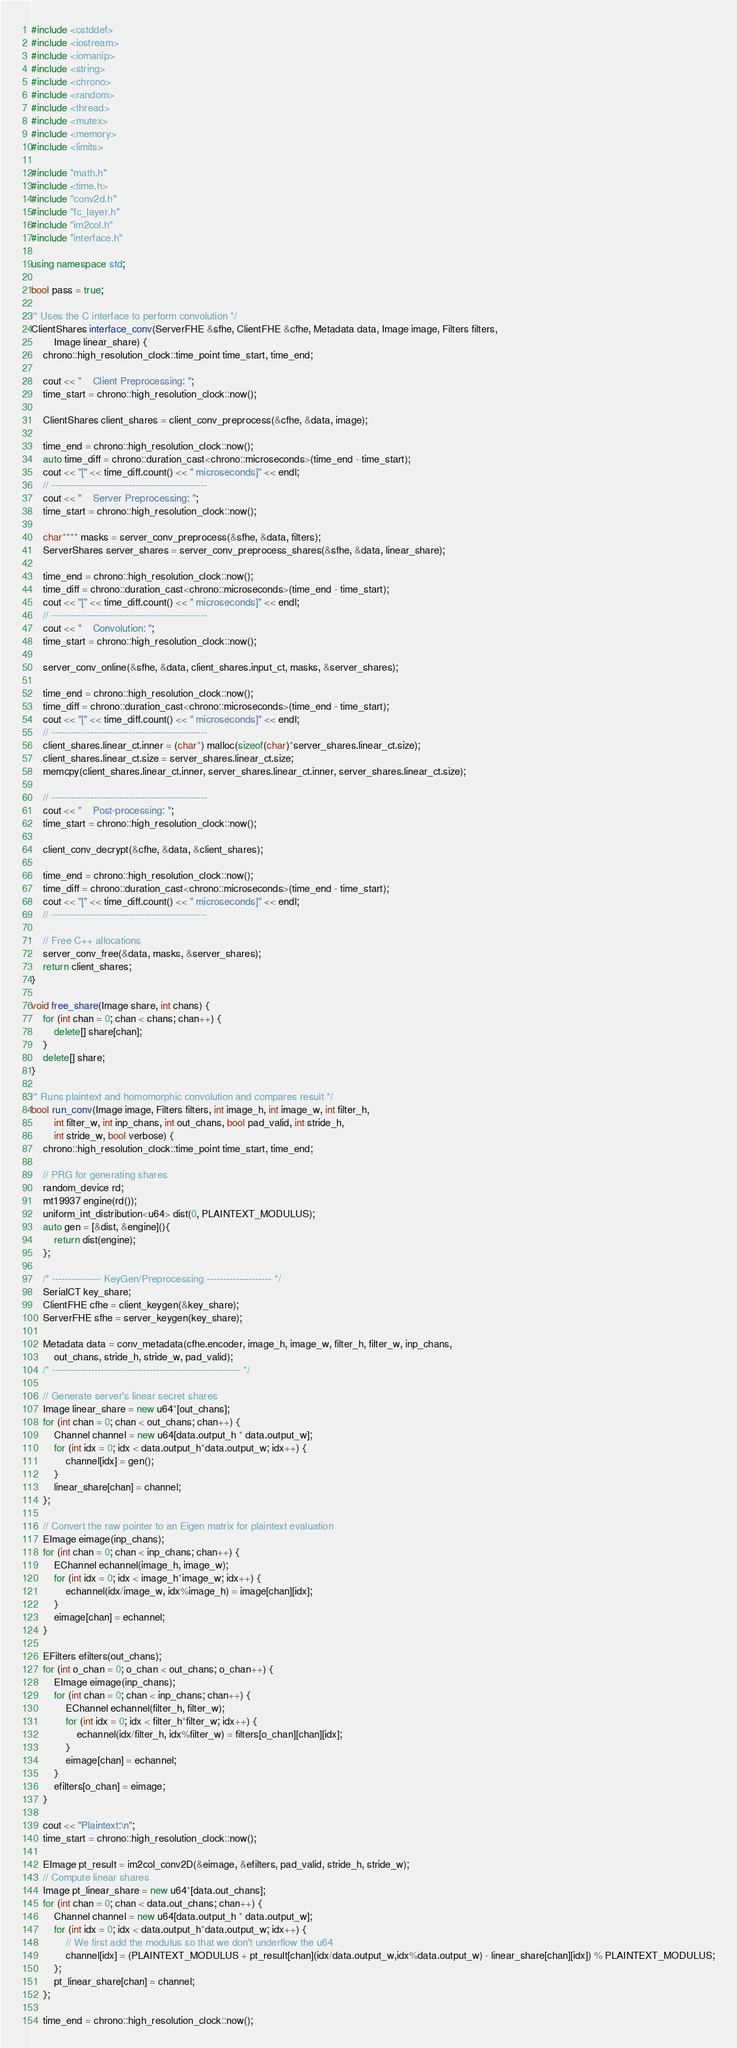<code> <loc_0><loc_0><loc_500><loc_500><_C++_>#include <cstddef>
#include <iostream>
#include <iomanip>
#include <string>
#include <chrono>
#include <random>
#include <thread>
#include <mutex>
#include <memory>
#include <limits>

#include "math.h"
#include <time.h>
#include "conv2d.h"
#include "fc_layer.h"
#include "im2col.h"
#include "interface.h"

using namespace std;

bool pass = true;

/* Uses the C interface to perform convolution */
ClientShares interface_conv(ServerFHE &sfhe, ClientFHE &cfhe, Metadata data, Image image, Filters filters,
        Image linear_share) {
    chrono::high_resolution_clock::time_point time_start, time_end;

    cout << "    Client Preprocessing: ";
    time_start = chrono::high_resolution_clock::now();

    ClientShares client_shares = client_conv_preprocess(&cfhe, &data, image);
    
    time_end = chrono::high_resolution_clock::now();
    auto time_diff = chrono::duration_cast<chrono::microseconds>(time_end - time_start);
    cout << "[" << time_diff.count() << " microseconds]" << endl;
    // ------------------------------------------------ 
    cout << "    Server Preprocessing: ";
    time_start = chrono::high_resolution_clock::now();

    char**** masks = server_conv_preprocess(&sfhe, &data, filters);
    ServerShares server_shares = server_conv_preprocess_shares(&sfhe, &data, linear_share);
    
    time_end = chrono::high_resolution_clock::now();
    time_diff = chrono::duration_cast<chrono::microseconds>(time_end - time_start);
    cout << "[" << time_diff.count() << " microseconds]" << endl;
    // ------------------------------------------------ 
    cout << "    Convolution: ";
    time_start = chrono::high_resolution_clock::now();
    
    server_conv_online(&sfhe, &data, client_shares.input_ct, masks, &server_shares);
    
    time_end = chrono::high_resolution_clock::now();
    time_diff = chrono::duration_cast<chrono::microseconds>(time_end - time_start);
    cout << "[" << time_diff.count() << " microseconds]" << endl;
    // ------------------------------------------------ 
    client_shares.linear_ct.inner = (char*) malloc(sizeof(char)*server_shares.linear_ct.size);
    client_shares.linear_ct.size = server_shares.linear_ct.size;
    memcpy(client_shares.linear_ct.inner, server_shares.linear_ct.inner, server_shares.linear_ct.size);

    // ------------------------------------------------ 
    cout << "    Post-processing: ";
    time_start = chrono::high_resolution_clock::now();

    client_conv_decrypt(&cfhe, &data, &client_shares);
    
    time_end = chrono::high_resolution_clock::now();
    time_diff = chrono::duration_cast<chrono::microseconds>(time_end - time_start);
    cout << "[" << time_diff.count() << " microseconds]" << endl;
    // ------------------------------------------------ 
  
    // Free C++ allocations
    server_conv_free(&data, masks, &server_shares);
    return client_shares;
}

void free_share(Image share, int chans) {
    for (int chan = 0; chan < chans; chan++) {
        delete[] share[chan];
    }
    delete[] share;
}

/* Runs plaintext and homomorphic convolution and compares result */
bool run_conv(Image image, Filters filters, int image_h, int image_w, int filter_h,
        int filter_w, int inp_chans, int out_chans, bool pad_valid, int stride_h,
        int stride_w, bool verbose) {
    chrono::high_resolution_clock::time_point time_start, time_end;
    
    // PRG for generating shares
    random_device rd;
    mt19937 engine(rd());
    uniform_int_distribution<u64> dist(0, PLAINTEXT_MODULUS);
    auto gen = [&dist, &engine](){
        return dist(engine);
    };

    /* --------------- KeyGen/Preprocessing -------------------- */
    SerialCT key_share;
    ClientFHE cfhe = client_keygen(&key_share);
    ServerFHE sfhe = server_keygen(key_share); 
    
    Metadata data = conv_metadata(cfhe.encoder, image_h, image_w, filter_h, filter_w, inp_chans, 
        out_chans, stride_h, stride_w, pad_valid);
    /* ---------------------------------------------------------- */

    // Generate server's linear secret shares
    Image linear_share = new u64*[out_chans];
    for (int chan = 0; chan < out_chans; chan++) {
        Channel channel = new u64[data.output_h * data.output_w];
        for (int idx = 0; idx < data.output_h*data.output_w; idx++) {
            channel[idx] = gen();
        }
        linear_share[chan] = channel;
    };

    // Convert the raw pointer to an Eigen matrix for plaintext evaluation
    EImage eimage(inp_chans);
    for (int chan = 0; chan < inp_chans; chan++) {
        EChannel echannel(image_h, image_w);
        for (int idx = 0; idx < image_h*image_w; idx++) {
            echannel(idx/image_w, idx%image_h) = image[chan][idx];
        }
        eimage[chan] = echannel;
    }

    EFilters efilters(out_chans);
    for (int o_chan = 0; o_chan < out_chans; o_chan++) {
        EImage eimage(inp_chans);
        for (int chan = 0; chan < inp_chans; chan++) {
            EChannel echannel(filter_h, filter_w);
            for (int idx = 0; idx < filter_h*filter_w; idx++) {
                echannel(idx/filter_h, idx%filter_w) = filters[o_chan][chan][idx];
            }
            eimage[chan] = echannel;
        }
        efilters[o_chan] = eimage;
    }

    cout << "Plaintext:\n";
    time_start = chrono::high_resolution_clock::now();

    EImage pt_result = im2col_conv2D(&eimage, &efilters, pad_valid, stride_h, stride_w);
    // Compute linear shares 
    Image pt_linear_share = new u64*[data.out_chans];
    for (int chan = 0; chan < data.out_chans; chan++) {
        Channel channel = new u64[data.output_h * data.output_w];
        for (int idx = 0; idx < data.output_h*data.output_w; idx++) {
            // We first add the modulus so that we don't underflow the u64
            channel[idx] = (PLAINTEXT_MODULUS + pt_result[chan](idx/data.output_w,idx%data.output_w) - linear_share[chan][idx]) % PLAINTEXT_MODULUS;
        };
        pt_linear_share[chan] = channel;
    };
    
    time_end = chrono::high_resolution_clock::now();</code> 